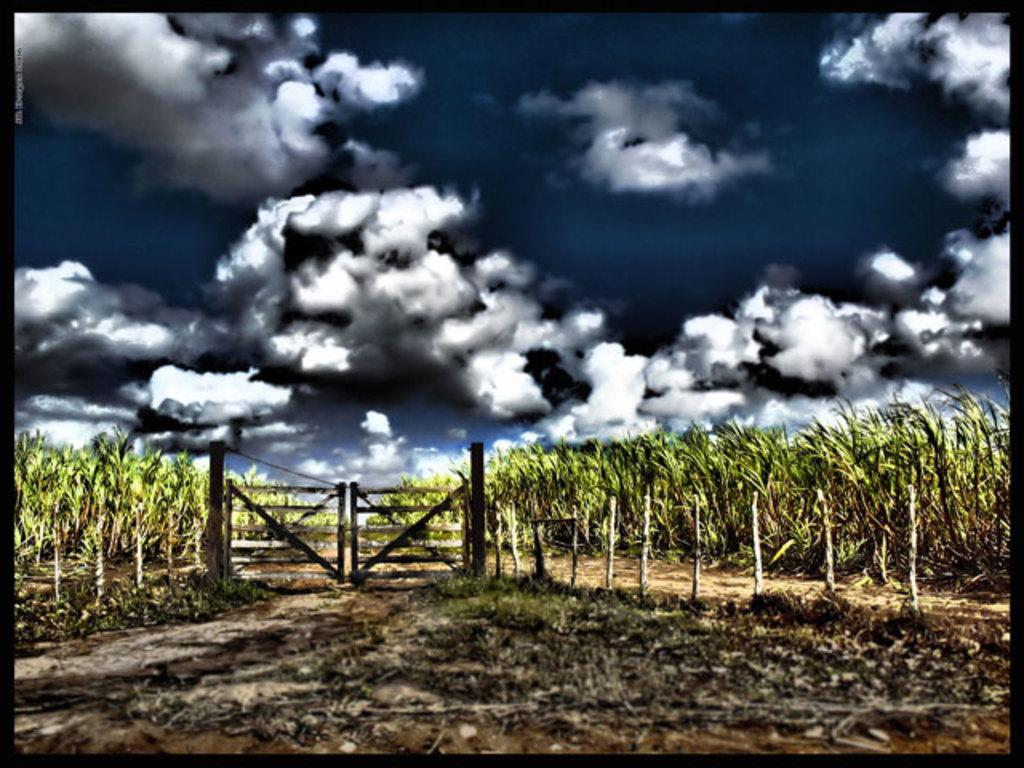What type of vegetation is present in the front of the image? There is dry grass in the front of the image. What structure can be seen in the center of the image? There is a gate in the center of the image. What can be seen in the background of the image? There are plants in the background of the image. How would you describe the sky in the image? The sky is cloudy in the image. Has the image been altered in any way? Yes, the image has been edited. What type of whip is being used by the manager in the image? There is no manager or whip present in the image. What is the wish of the person standing next to the gate in the image? There is no person standing next to the gate in the image. 